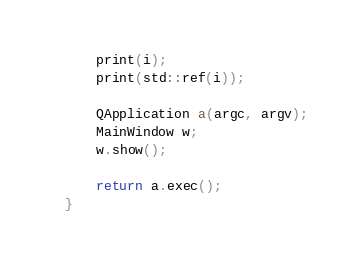Convert code to text. <code><loc_0><loc_0><loc_500><loc_500><_C++_>
    print(i);
    print(std::ref(i));

    QApplication a(argc, argv);
    MainWindow w;
    w.show();

    return a.exec();
}
</code> 